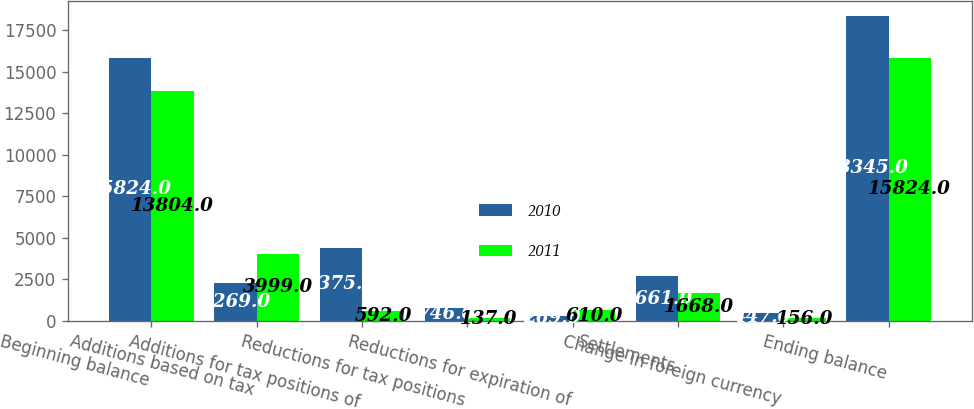Convert chart to OTSL. <chart><loc_0><loc_0><loc_500><loc_500><stacked_bar_chart><ecel><fcel>Beginning balance<fcel>Additions based on tax<fcel>Additions for tax positions of<fcel>Reductions for tax positions<fcel>Reductions for expiration of<fcel>Settlements<fcel>Change in foreign currency<fcel>Ending balance<nl><fcel>2010<fcel>15824<fcel>2269<fcel>4375<fcel>746<fcel>269<fcel>2661<fcel>447<fcel>18345<nl><fcel>2011<fcel>13804<fcel>3999<fcel>592<fcel>137<fcel>610<fcel>1668<fcel>156<fcel>15824<nl></chart> 